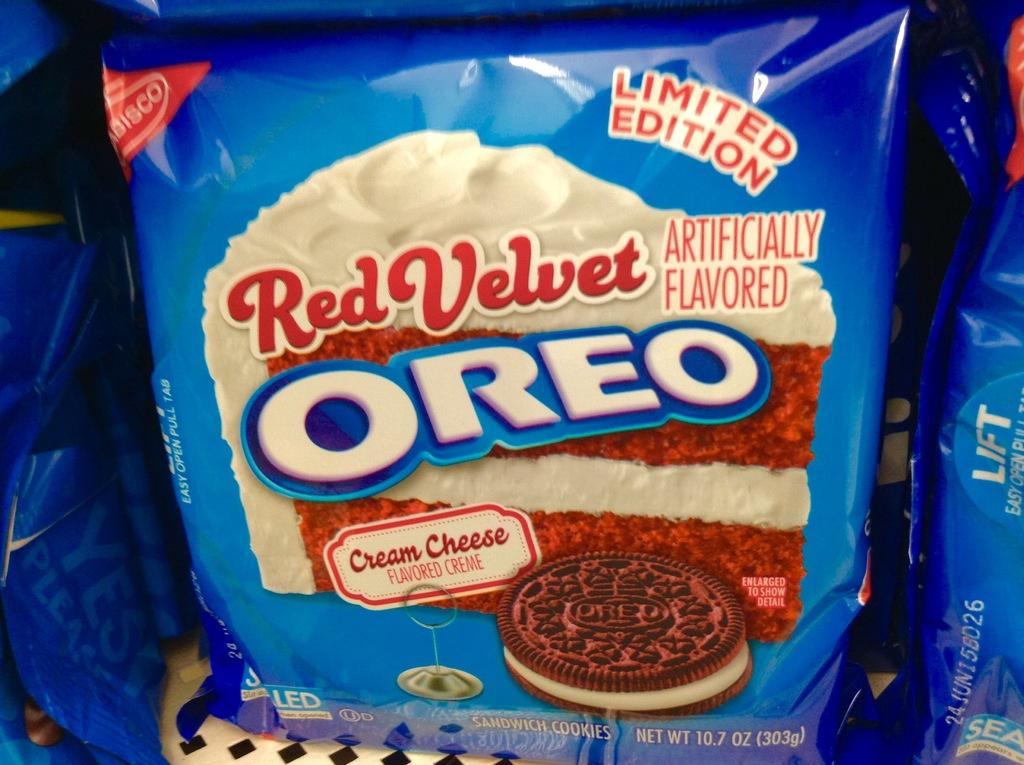What type of food item is visible in the image? There are packs of Oreo biscuits in the image. What type of plot can be seen in the background of the image? There is no plot visible in the image; it only shows packs of Oreo biscuits. 